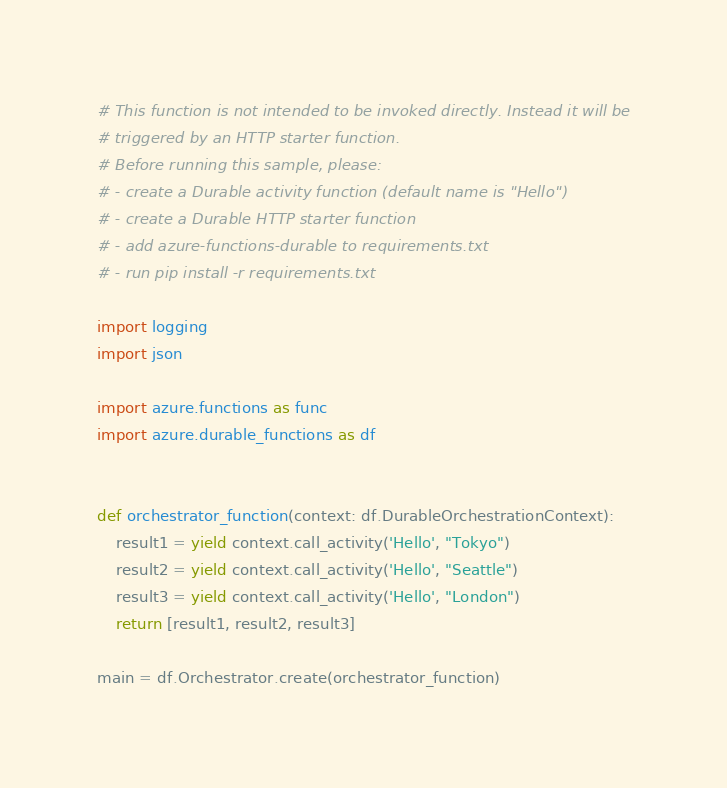Convert code to text. <code><loc_0><loc_0><loc_500><loc_500><_Python_># This function is not intended to be invoked directly. Instead it will be
# triggered by an HTTP starter function.
# Before running this sample, please:
# - create a Durable activity function (default name is "Hello")
# - create a Durable HTTP starter function
# - add azure-functions-durable to requirements.txt
# - run pip install -r requirements.txt

import logging
import json

import azure.functions as func
import azure.durable_functions as df


def orchestrator_function(context: df.DurableOrchestrationContext):
    result1 = yield context.call_activity('Hello', "Tokyo")
    result2 = yield context.call_activity('Hello', "Seattle")
    result3 = yield context.call_activity('Hello', "London")
    return [result1, result2, result3]

main = df.Orchestrator.create(orchestrator_function)</code> 